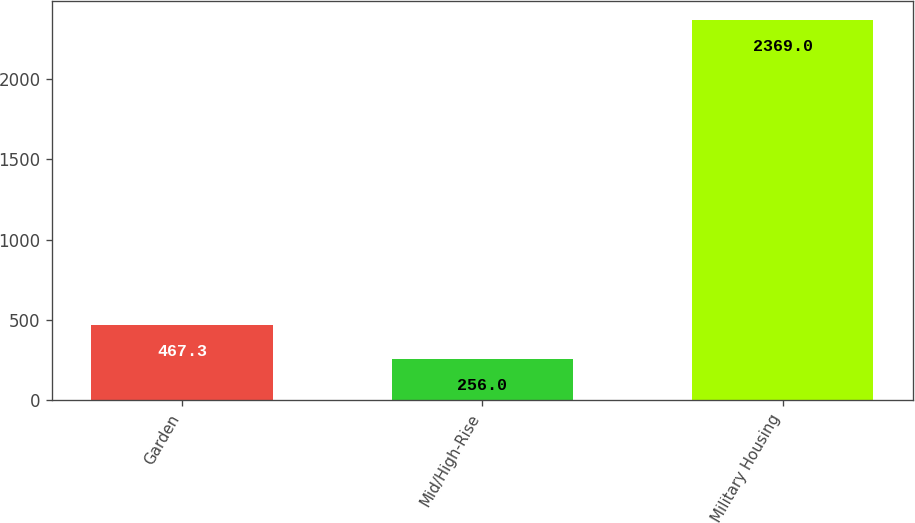Convert chart. <chart><loc_0><loc_0><loc_500><loc_500><bar_chart><fcel>Garden<fcel>Mid/High-Rise<fcel>Military Housing<nl><fcel>467.3<fcel>256<fcel>2369<nl></chart> 